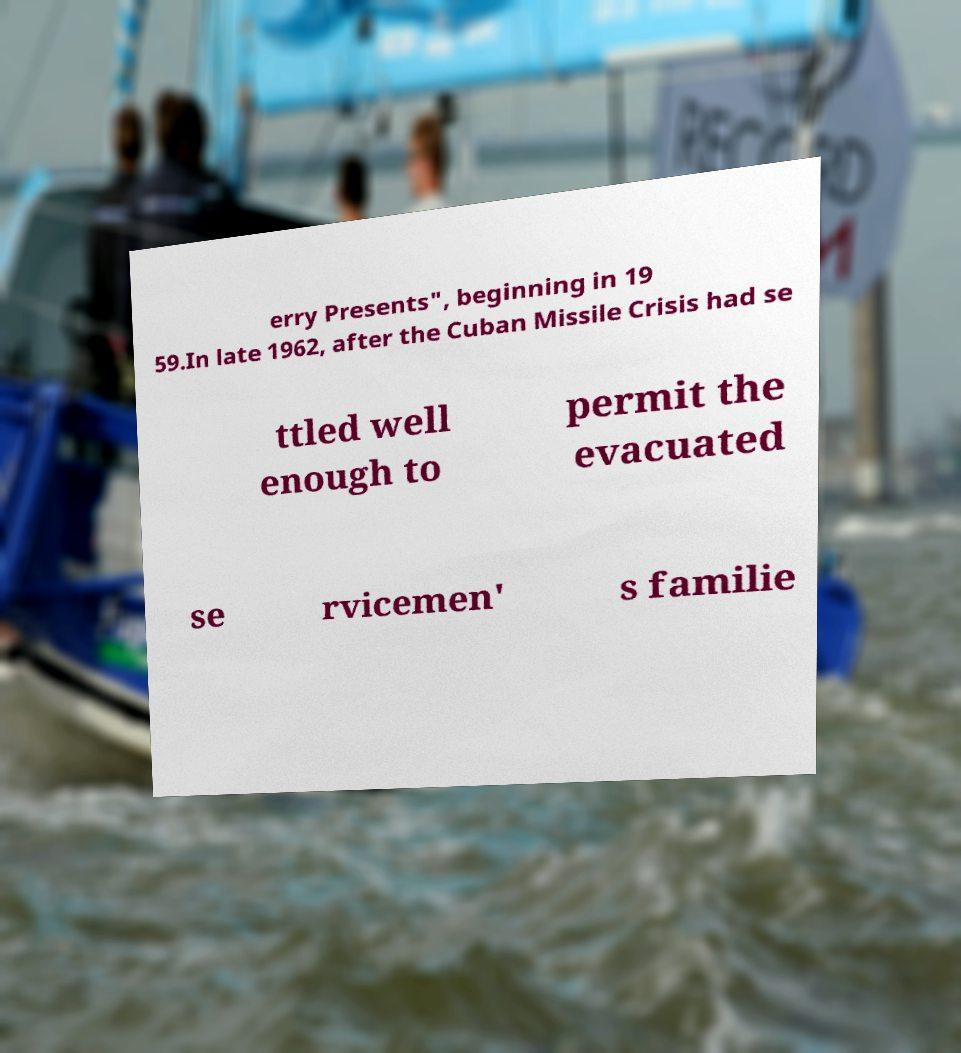For documentation purposes, I need the text within this image transcribed. Could you provide that? erry Presents", beginning in 19 59.In late 1962, after the Cuban Missile Crisis had se ttled well enough to permit the evacuated se rvicemen' s familie 